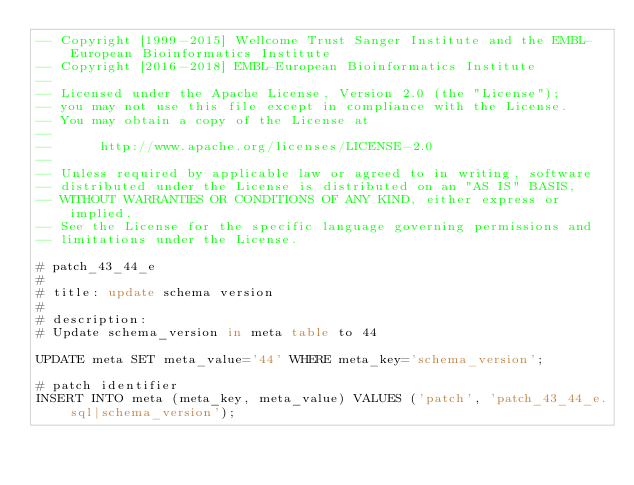Convert code to text. <code><loc_0><loc_0><loc_500><loc_500><_SQL_>-- Copyright [1999-2015] Wellcome Trust Sanger Institute and the EMBL-European Bioinformatics Institute
-- Copyright [2016-2018] EMBL-European Bioinformatics Institute
-- 
-- Licensed under the Apache License, Version 2.0 (the "License");
-- you may not use this file except in compliance with the License.
-- You may obtain a copy of the License at
-- 
--      http://www.apache.org/licenses/LICENSE-2.0
-- 
-- Unless required by applicable law or agreed to in writing, software
-- distributed under the License is distributed on an "AS IS" BASIS,
-- WITHOUT WARRANTIES OR CONDITIONS OF ANY KIND, either express or implied.
-- See the License for the specific language governing permissions and
-- limitations under the License.

# patch_43_44_e
#
# title: update schema version
#
# description:
# Update schema_version in meta table to 44

UPDATE meta SET meta_value='44' WHERE meta_key='schema_version';

# patch identifier
INSERT INTO meta (meta_key, meta_value) VALUES ('patch', 'patch_43_44_e.sql|schema_version');


</code> 